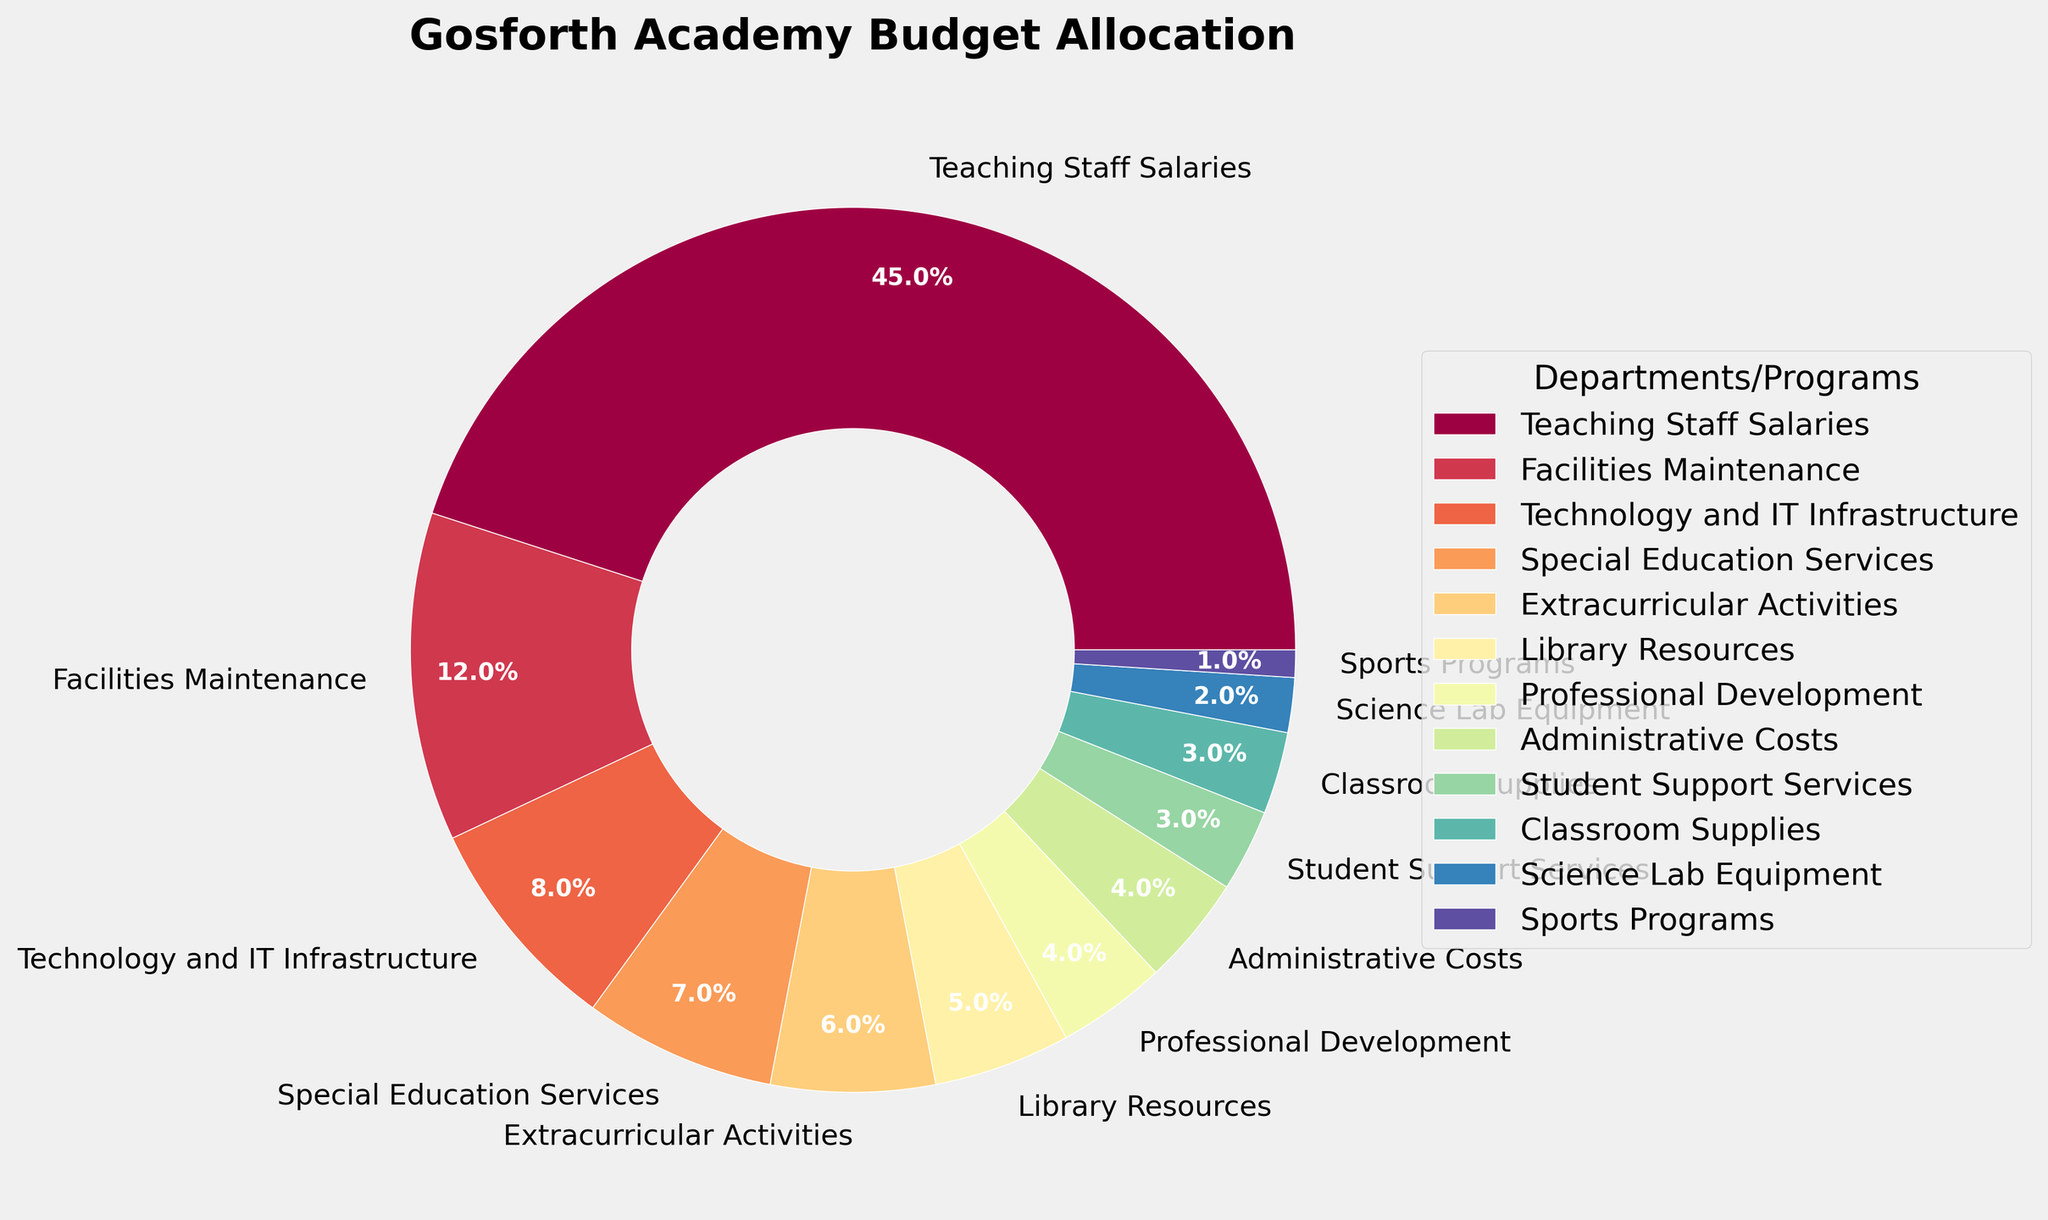Which department or program receives the largest portion of the budget? The figure shows a pie chart where the largest wedge corresponds to "Teaching Staff Salaries." The label indicates that this department receives 45% of the budget.
Answer: Teaching Staff Salaries What is the combined budget allocation for Library Resources and Professional Development? Library Resources receives 5% of the budget and Professional Development receives 4%. Adding these percentages together, we get 5% + 4% = 9%.
Answer: 9% Which department receives a higher budget allocation: Extracurricular Activities or Classroom Supplies? The pie chart shows that Extracurricular Activities receives 6%, while Classroom Supplies receives 3%. Since 6% is greater than 3%, Extracurricular Activities receives a higher budget allocation.
Answer: Extracurricular Activities How many departments or programs receive a budget allocation of less than 5%? By examining the chart, the following budget allocations are less than 5%: Professional Development (4%), Administrative Costs (4%), Student Support Services (3%), Classroom Supplies (3%), Science Lab Equipment (2%), and Sports Programs (1%). Counting these, we get 6 departments or programs.
Answer: 6 What is the difference in budget allocation between Technology & IT Infrastructure and Special Education Services? Technology & IT Infrastructure receives 8% of the budget while Special Education Services receives 7%. The difference in their budget allocations is 8% - 7% = 1%.
Answer: 1% Does the administrative cost account for a greater proportion of the budget than Student Support Services? The pie chart shows that Administrative Costs account for 4% of the budget whereas Student Support Services account for 3%. Since 4% is greater than 3%, Administrative Costs account for a greater proportion of the budget.
Answer: Yes Which three departments or programs have the lowest budget allocations individually? The three smallest wedges in the pie chart are for Science Lab Equipment (2%), Sports Programs (1%), and Student Support Services (3%).
Answer: Science Lab Equipment, Sports Programs, Student Support Services What is the total budget allocation for all departments and programs that receive exactly 4%? The pie chart shows that two departments receive exactly 4% each: Professional Development and Administrative Costs. Summing these, we get 4% + 4% = 8%.
Answer: 8% Which department or program has a budget allocation that is visually displayed in green in the pie chart? Upon examining the colors, the department corresponding to the green segment is "Facilities Maintenance," which has a budget allocation of 12%.
Answer: Facilities Maintenance 